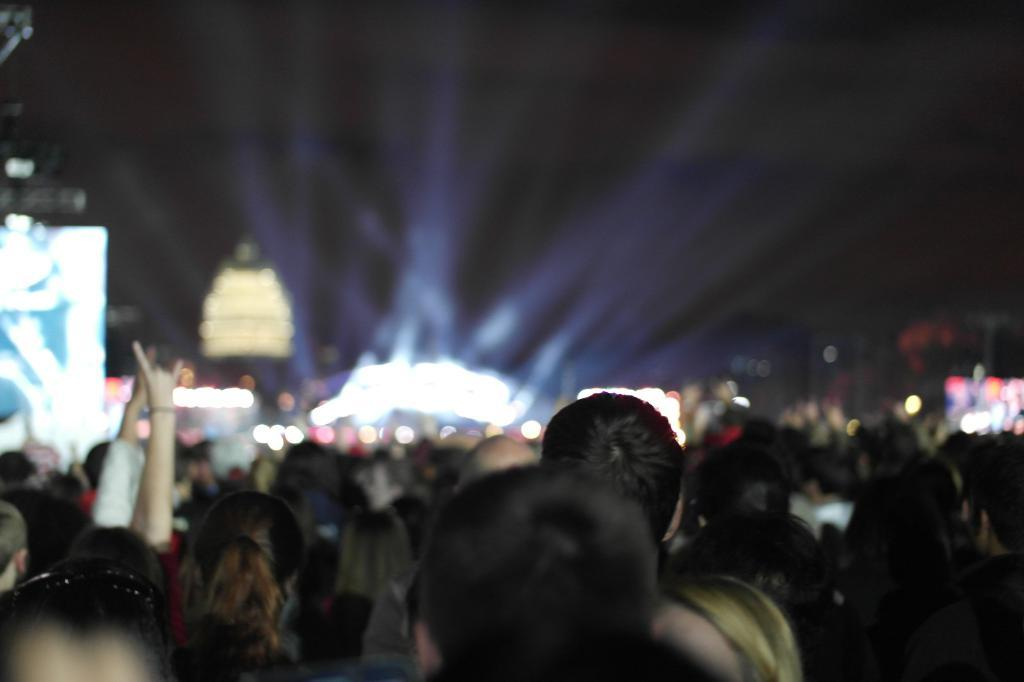What can be seen in the foreground of the image? There is a group of people in the foreground of the image. What is the condition of the background in the image? The background of the image is blurred. What type of club is being held by the people in the image? There is no club visible in the image; it only shows a group of people and a blurred background. 